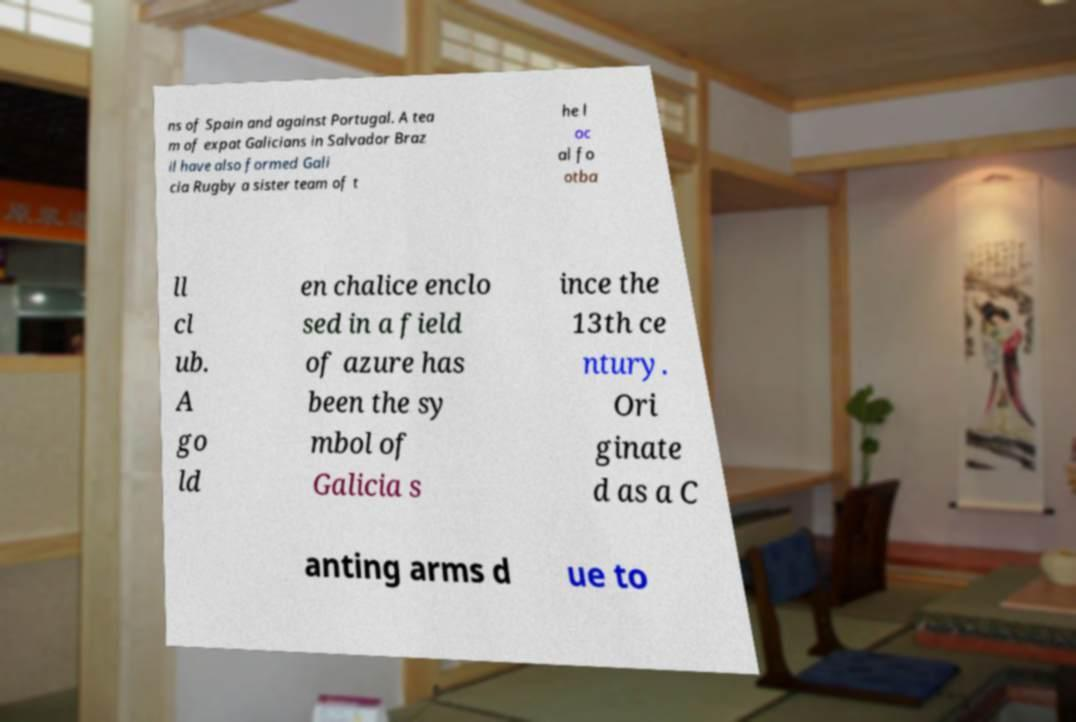Can you read and provide the text displayed in the image?This photo seems to have some interesting text. Can you extract and type it out for me? ns of Spain and against Portugal. A tea m of expat Galicians in Salvador Braz il have also formed Gali cia Rugby a sister team of t he l oc al fo otba ll cl ub. A go ld en chalice enclo sed in a field of azure has been the sy mbol of Galicia s ince the 13th ce ntury. Ori ginate d as a C anting arms d ue to 